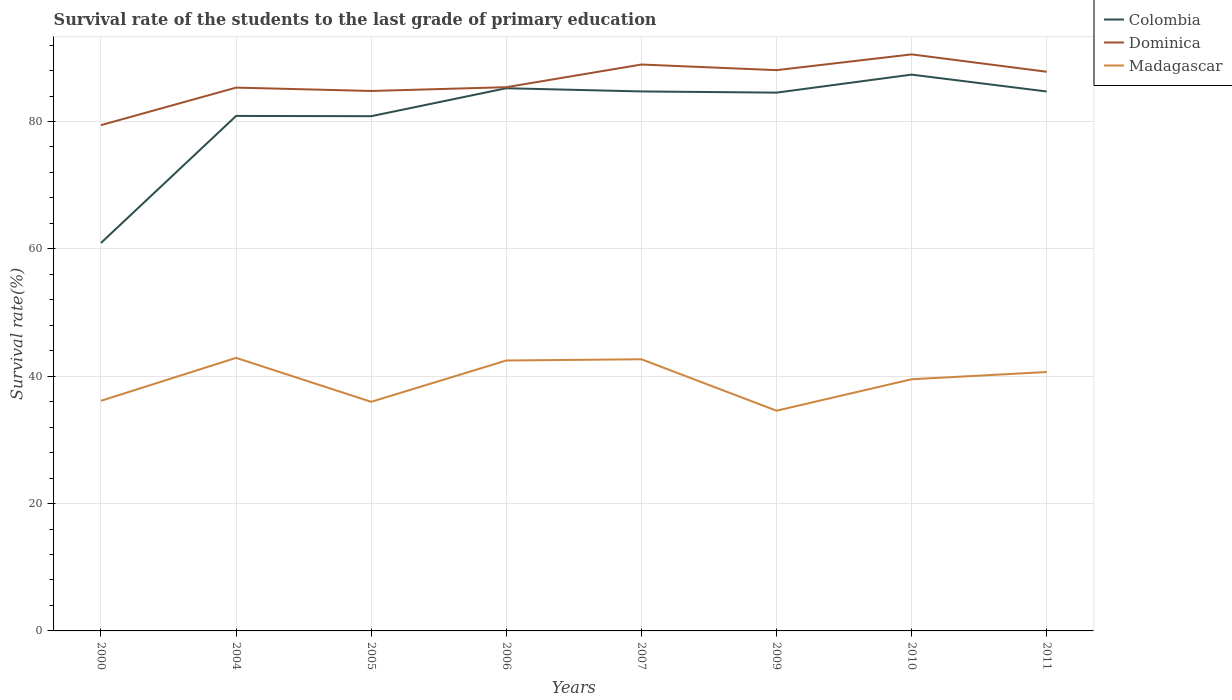Does the line corresponding to Colombia intersect with the line corresponding to Dominica?
Provide a succinct answer. No. Across all years, what is the maximum survival rate of the students in Dominica?
Your response must be concise. 79.43. In which year was the survival rate of the students in Madagascar maximum?
Your answer should be very brief. 2009. What is the total survival rate of the students in Madagascar in the graph?
Your answer should be very brief. 8.3. What is the difference between the highest and the second highest survival rate of the students in Dominica?
Ensure brevity in your answer.  11.11. Is the survival rate of the students in Dominica strictly greater than the survival rate of the students in Colombia over the years?
Make the answer very short. No. How many lines are there?
Your response must be concise. 3. How many years are there in the graph?
Provide a short and direct response. 8. What is the difference between two consecutive major ticks on the Y-axis?
Your answer should be very brief. 20. Are the values on the major ticks of Y-axis written in scientific E-notation?
Offer a terse response. No. Where does the legend appear in the graph?
Make the answer very short. Top right. How are the legend labels stacked?
Make the answer very short. Vertical. What is the title of the graph?
Provide a short and direct response. Survival rate of the students to the last grade of primary education. Does "Colombia" appear as one of the legend labels in the graph?
Provide a short and direct response. Yes. What is the label or title of the X-axis?
Keep it short and to the point. Years. What is the label or title of the Y-axis?
Your response must be concise. Survival rate(%). What is the Survival rate(%) of Colombia in 2000?
Provide a succinct answer. 60.93. What is the Survival rate(%) of Dominica in 2000?
Your response must be concise. 79.43. What is the Survival rate(%) in Madagascar in 2000?
Make the answer very short. 36.14. What is the Survival rate(%) of Colombia in 2004?
Offer a terse response. 80.87. What is the Survival rate(%) in Dominica in 2004?
Your answer should be compact. 85.32. What is the Survival rate(%) of Madagascar in 2004?
Your answer should be very brief. 42.88. What is the Survival rate(%) in Colombia in 2005?
Provide a short and direct response. 80.83. What is the Survival rate(%) in Dominica in 2005?
Ensure brevity in your answer.  84.79. What is the Survival rate(%) of Madagascar in 2005?
Keep it short and to the point. 35.98. What is the Survival rate(%) of Colombia in 2006?
Give a very brief answer. 85.22. What is the Survival rate(%) in Dominica in 2006?
Provide a short and direct response. 85.39. What is the Survival rate(%) in Madagascar in 2006?
Offer a terse response. 42.47. What is the Survival rate(%) of Colombia in 2007?
Provide a succinct answer. 84.72. What is the Survival rate(%) of Dominica in 2007?
Your answer should be compact. 88.94. What is the Survival rate(%) in Madagascar in 2007?
Your answer should be very brief. 42.66. What is the Survival rate(%) of Colombia in 2009?
Your answer should be compact. 84.53. What is the Survival rate(%) in Dominica in 2009?
Provide a succinct answer. 88.06. What is the Survival rate(%) of Madagascar in 2009?
Your answer should be compact. 34.58. What is the Survival rate(%) in Colombia in 2010?
Ensure brevity in your answer.  87.36. What is the Survival rate(%) of Dominica in 2010?
Ensure brevity in your answer.  90.54. What is the Survival rate(%) in Madagascar in 2010?
Ensure brevity in your answer.  39.52. What is the Survival rate(%) of Colombia in 2011?
Ensure brevity in your answer.  84.71. What is the Survival rate(%) in Dominica in 2011?
Your answer should be compact. 87.81. What is the Survival rate(%) of Madagascar in 2011?
Provide a succinct answer. 40.66. Across all years, what is the maximum Survival rate(%) of Colombia?
Keep it short and to the point. 87.36. Across all years, what is the maximum Survival rate(%) in Dominica?
Ensure brevity in your answer.  90.54. Across all years, what is the maximum Survival rate(%) in Madagascar?
Keep it short and to the point. 42.88. Across all years, what is the minimum Survival rate(%) of Colombia?
Provide a short and direct response. 60.93. Across all years, what is the minimum Survival rate(%) in Dominica?
Give a very brief answer. 79.43. Across all years, what is the minimum Survival rate(%) of Madagascar?
Provide a succinct answer. 34.58. What is the total Survival rate(%) of Colombia in the graph?
Offer a very short reply. 649.19. What is the total Survival rate(%) of Dominica in the graph?
Offer a terse response. 690.28. What is the total Survival rate(%) in Madagascar in the graph?
Offer a very short reply. 314.89. What is the difference between the Survival rate(%) of Colombia in 2000 and that in 2004?
Your answer should be compact. -19.94. What is the difference between the Survival rate(%) of Dominica in 2000 and that in 2004?
Provide a succinct answer. -5.89. What is the difference between the Survival rate(%) of Madagascar in 2000 and that in 2004?
Make the answer very short. -6.74. What is the difference between the Survival rate(%) in Colombia in 2000 and that in 2005?
Make the answer very short. -19.9. What is the difference between the Survival rate(%) in Dominica in 2000 and that in 2005?
Your response must be concise. -5.37. What is the difference between the Survival rate(%) in Madagascar in 2000 and that in 2005?
Provide a succinct answer. 0.16. What is the difference between the Survival rate(%) of Colombia in 2000 and that in 2006?
Your answer should be compact. -24.29. What is the difference between the Survival rate(%) in Dominica in 2000 and that in 2006?
Ensure brevity in your answer.  -5.96. What is the difference between the Survival rate(%) of Madagascar in 2000 and that in 2006?
Keep it short and to the point. -6.33. What is the difference between the Survival rate(%) of Colombia in 2000 and that in 2007?
Provide a short and direct response. -23.79. What is the difference between the Survival rate(%) of Dominica in 2000 and that in 2007?
Ensure brevity in your answer.  -9.52. What is the difference between the Survival rate(%) of Madagascar in 2000 and that in 2007?
Your answer should be compact. -6.52. What is the difference between the Survival rate(%) in Colombia in 2000 and that in 2009?
Give a very brief answer. -23.6. What is the difference between the Survival rate(%) of Dominica in 2000 and that in 2009?
Provide a succinct answer. -8.64. What is the difference between the Survival rate(%) in Madagascar in 2000 and that in 2009?
Provide a succinct answer. 1.56. What is the difference between the Survival rate(%) of Colombia in 2000 and that in 2010?
Provide a succinct answer. -26.43. What is the difference between the Survival rate(%) in Dominica in 2000 and that in 2010?
Give a very brief answer. -11.11. What is the difference between the Survival rate(%) of Madagascar in 2000 and that in 2010?
Provide a short and direct response. -3.38. What is the difference between the Survival rate(%) of Colombia in 2000 and that in 2011?
Offer a very short reply. -23.78. What is the difference between the Survival rate(%) of Dominica in 2000 and that in 2011?
Offer a terse response. -8.38. What is the difference between the Survival rate(%) of Madagascar in 2000 and that in 2011?
Give a very brief answer. -4.52. What is the difference between the Survival rate(%) of Colombia in 2004 and that in 2005?
Keep it short and to the point. 0.04. What is the difference between the Survival rate(%) of Dominica in 2004 and that in 2005?
Provide a succinct answer. 0.53. What is the difference between the Survival rate(%) in Madagascar in 2004 and that in 2005?
Give a very brief answer. 6.9. What is the difference between the Survival rate(%) of Colombia in 2004 and that in 2006?
Offer a terse response. -4.35. What is the difference between the Survival rate(%) of Dominica in 2004 and that in 2006?
Offer a terse response. -0.07. What is the difference between the Survival rate(%) of Madagascar in 2004 and that in 2006?
Keep it short and to the point. 0.42. What is the difference between the Survival rate(%) in Colombia in 2004 and that in 2007?
Your answer should be very brief. -3.85. What is the difference between the Survival rate(%) in Dominica in 2004 and that in 2007?
Provide a short and direct response. -3.62. What is the difference between the Survival rate(%) of Madagascar in 2004 and that in 2007?
Offer a terse response. 0.22. What is the difference between the Survival rate(%) of Colombia in 2004 and that in 2009?
Keep it short and to the point. -3.66. What is the difference between the Survival rate(%) of Dominica in 2004 and that in 2009?
Offer a very short reply. -2.74. What is the difference between the Survival rate(%) of Madagascar in 2004 and that in 2009?
Your answer should be compact. 8.3. What is the difference between the Survival rate(%) of Colombia in 2004 and that in 2010?
Offer a very short reply. -6.49. What is the difference between the Survival rate(%) in Dominica in 2004 and that in 2010?
Provide a succinct answer. -5.22. What is the difference between the Survival rate(%) of Madagascar in 2004 and that in 2010?
Provide a short and direct response. 3.36. What is the difference between the Survival rate(%) in Colombia in 2004 and that in 2011?
Your answer should be very brief. -3.84. What is the difference between the Survival rate(%) in Dominica in 2004 and that in 2011?
Offer a terse response. -2.49. What is the difference between the Survival rate(%) of Madagascar in 2004 and that in 2011?
Your answer should be very brief. 2.22. What is the difference between the Survival rate(%) in Colombia in 2005 and that in 2006?
Your answer should be compact. -4.39. What is the difference between the Survival rate(%) of Dominica in 2005 and that in 2006?
Offer a very short reply. -0.59. What is the difference between the Survival rate(%) in Madagascar in 2005 and that in 2006?
Ensure brevity in your answer.  -6.49. What is the difference between the Survival rate(%) of Colombia in 2005 and that in 2007?
Provide a short and direct response. -3.89. What is the difference between the Survival rate(%) in Dominica in 2005 and that in 2007?
Make the answer very short. -4.15. What is the difference between the Survival rate(%) in Madagascar in 2005 and that in 2007?
Give a very brief answer. -6.68. What is the difference between the Survival rate(%) of Colombia in 2005 and that in 2009?
Your answer should be very brief. -3.7. What is the difference between the Survival rate(%) in Dominica in 2005 and that in 2009?
Provide a succinct answer. -3.27. What is the difference between the Survival rate(%) of Madagascar in 2005 and that in 2009?
Your answer should be very brief. 1.39. What is the difference between the Survival rate(%) in Colombia in 2005 and that in 2010?
Your answer should be very brief. -6.53. What is the difference between the Survival rate(%) of Dominica in 2005 and that in 2010?
Make the answer very short. -5.75. What is the difference between the Survival rate(%) of Madagascar in 2005 and that in 2010?
Your answer should be compact. -3.54. What is the difference between the Survival rate(%) in Colombia in 2005 and that in 2011?
Offer a terse response. -3.88. What is the difference between the Survival rate(%) of Dominica in 2005 and that in 2011?
Your answer should be very brief. -3.02. What is the difference between the Survival rate(%) of Madagascar in 2005 and that in 2011?
Offer a terse response. -4.68. What is the difference between the Survival rate(%) in Colombia in 2006 and that in 2007?
Provide a short and direct response. 0.5. What is the difference between the Survival rate(%) in Dominica in 2006 and that in 2007?
Your response must be concise. -3.56. What is the difference between the Survival rate(%) of Madagascar in 2006 and that in 2007?
Keep it short and to the point. -0.19. What is the difference between the Survival rate(%) of Colombia in 2006 and that in 2009?
Your answer should be compact. 0.69. What is the difference between the Survival rate(%) in Dominica in 2006 and that in 2009?
Offer a terse response. -2.68. What is the difference between the Survival rate(%) in Madagascar in 2006 and that in 2009?
Offer a terse response. 7.88. What is the difference between the Survival rate(%) in Colombia in 2006 and that in 2010?
Provide a short and direct response. -2.14. What is the difference between the Survival rate(%) in Dominica in 2006 and that in 2010?
Your answer should be very brief. -5.15. What is the difference between the Survival rate(%) of Madagascar in 2006 and that in 2010?
Your response must be concise. 2.95. What is the difference between the Survival rate(%) of Colombia in 2006 and that in 2011?
Ensure brevity in your answer.  0.51. What is the difference between the Survival rate(%) of Dominica in 2006 and that in 2011?
Offer a very short reply. -2.42. What is the difference between the Survival rate(%) of Madagascar in 2006 and that in 2011?
Your answer should be very brief. 1.81. What is the difference between the Survival rate(%) of Colombia in 2007 and that in 2009?
Your answer should be compact. 0.19. What is the difference between the Survival rate(%) of Dominica in 2007 and that in 2009?
Make the answer very short. 0.88. What is the difference between the Survival rate(%) in Madagascar in 2007 and that in 2009?
Offer a very short reply. 8.08. What is the difference between the Survival rate(%) in Colombia in 2007 and that in 2010?
Provide a short and direct response. -2.64. What is the difference between the Survival rate(%) in Dominica in 2007 and that in 2010?
Keep it short and to the point. -1.59. What is the difference between the Survival rate(%) of Madagascar in 2007 and that in 2010?
Make the answer very short. 3.14. What is the difference between the Survival rate(%) of Colombia in 2007 and that in 2011?
Offer a terse response. 0.01. What is the difference between the Survival rate(%) of Dominica in 2007 and that in 2011?
Offer a terse response. 1.14. What is the difference between the Survival rate(%) in Madagascar in 2007 and that in 2011?
Give a very brief answer. 2. What is the difference between the Survival rate(%) of Colombia in 2009 and that in 2010?
Your answer should be very brief. -2.83. What is the difference between the Survival rate(%) in Dominica in 2009 and that in 2010?
Provide a short and direct response. -2.47. What is the difference between the Survival rate(%) of Madagascar in 2009 and that in 2010?
Provide a short and direct response. -4.93. What is the difference between the Survival rate(%) in Colombia in 2009 and that in 2011?
Offer a terse response. -0.18. What is the difference between the Survival rate(%) in Dominica in 2009 and that in 2011?
Your answer should be very brief. 0.25. What is the difference between the Survival rate(%) of Madagascar in 2009 and that in 2011?
Your answer should be very brief. -6.07. What is the difference between the Survival rate(%) in Colombia in 2010 and that in 2011?
Your answer should be very brief. 2.65. What is the difference between the Survival rate(%) in Dominica in 2010 and that in 2011?
Make the answer very short. 2.73. What is the difference between the Survival rate(%) in Madagascar in 2010 and that in 2011?
Offer a very short reply. -1.14. What is the difference between the Survival rate(%) in Colombia in 2000 and the Survival rate(%) in Dominica in 2004?
Provide a succinct answer. -24.39. What is the difference between the Survival rate(%) in Colombia in 2000 and the Survival rate(%) in Madagascar in 2004?
Offer a terse response. 18.05. What is the difference between the Survival rate(%) in Dominica in 2000 and the Survival rate(%) in Madagascar in 2004?
Keep it short and to the point. 36.55. What is the difference between the Survival rate(%) of Colombia in 2000 and the Survival rate(%) of Dominica in 2005?
Your answer should be compact. -23.86. What is the difference between the Survival rate(%) in Colombia in 2000 and the Survival rate(%) in Madagascar in 2005?
Offer a terse response. 24.95. What is the difference between the Survival rate(%) in Dominica in 2000 and the Survival rate(%) in Madagascar in 2005?
Your answer should be very brief. 43.45. What is the difference between the Survival rate(%) of Colombia in 2000 and the Survival rate(%) of Dominica in 2006?
Your answer should be compact. -24.46. What is the difference between the Survival rate(%) of Colombia in 2000 and the Survival rate(%) of Madagascar in 2006?
Ensure brevity in your answer.  18.46. What is the difference between the Survival rate(%) in Dominica in 2000 and the Survival rate(%) in Madagascar in 2006?
Provide a short and direct response. 36.96. What is the difference between the Survival rate(%) in Colombia in 2000 and the Survival rate(%) in Dominica in 2007?
Provide a succinct answer. -28.01. What is the difference between the Survival rate(%) in Colombia in 2000 and the Survival rate(%) in Madagascar in 2007?
Offer a terse response. 18.27. What is the difference between the Survival rate(%) in Dominica in 2000 and the Survival rate(%) in Madagascar in 2007?
Offer a very short reply. 36.77. What is the difference between the Survival rate(%) of Colombia in 2000 and the Survival rate(%) of Dominica in 2009?
Provide a short and direct response. -27.13. What is the difference between the Survival rate(%) of Colombia in 2000 and the Survival rate(%) of Madagascar in 2009?
Offer a terse response. 26.35. What is the difference between the Survival rate(%) of Dominica in 2000 and the Survival rate(%) of Madagascar in 2009?
Make the answer very short. 44.84. What is the difference between the Survival rate(%) of Colombia in 2000 and the Survival rate(%) of Dominica in 2010?
Keep it short and to the point. -29.61. What is the difference between the Survival rate(%) in Colombia in 2000 and the Survival rate(%) in Madagascar in 2010?
Keep it short and to the point. 21.41. What is the difference between the Survival rate(%) in Dominica in 2000 and the Survival rate(%) in Madagascar in 2010?
Your answer should be very brief. 39.91. What is the difference between the Survival rate(%) in Colombia in 2000 and the Survival rate(%) in Dominica in 2011?
Your answer should be very brief. -26.88. What is the difference between the Survival rate(%) of Colombia in 2000 and the Survival rate(%) of Madagascar in 2011?
Your answer should be compact. 20.27. What is the difference between the Survival rate(%) in Dominica in 2000 and the Survival rate(%) in Madagascar in 2011?
Keep it short and to the point. 38.77. What is the difference between the Survival rate(%) of Colombia in 2004 and the Survival rate(%) of Dominica in 2005?
Offer a terse response. -3.92. What is the difference between the Survival rate(%) of Colombia in 2004 and the Survival rate(%) of Madagascar in 2005?
Keep it short and to the point. 44.89. What is the difference between the Survival rate(%) in Dominica in 2004 and the Survival rate(%) in Madagascar in 2005?
Provide a succinct answer. 49.34. What is the difference between the Survival rate(%) in Colombia in 2004 and the Survival rate(%) in Dominica in 2006?
Give a very brief answer. -4.51. What is the difference between the Survival rate(%) in Colombia in 2004 and the Survival rate(%) in Madagascar in 2006?
Provide a succinct answer. 38.41. What is the difference between the Survival rate(%) of Dominica in 2004 and the Survival rate(%) of Madagascar in 2006?
Make the answer very short. 42.85. What is the difference between the Survival rate(%) in Colombia in 2004 and the Survival rate(%) in Dominica in 2007?
Ensure brevity in your answer.  -8.07. What is the difference between the Survival rate(%) in Colombia in 2004 and the Survival rate(%) in Madagascar in 2007?
Keep it short and to the point. 38.21. What is the difference between the Survival rate(%) of Dominica in 2004 and the Survival rate(%) of Madagascar in 2007?
Offer a terse response. 42.66. What is the difference between the Survival rate(%) in Colombia in 2004 and the Survival rate(%) in Dominica in 2009?
Offer a very short reply. -7.19. What is the difference between the Survival rate(%) of Colombia in 2004 and the Survival rate(%) of Madagascar in 2009?
Ensure brevity in your answer.  46.29. What is the difference between the Survival rate(%) in Dominica in 2004 and the Survival rate(%) in Madagascar in 2009?
Give a very brief answer. 50.74. What is the difference between the Survival rate(%) of Colombia in 2004 and the Survival rate(%) of Dominica in 2010?
Make the answer very short. -9.67. What is the difference between the Survival rate(%) in Colombia in 2004 and the Survival rate(%) in Madagascar in 2010?
Your response must be concise. 41.35. What is the difference between the Survival rate(%) in Dominica in 2004 and the Survival rate(%) in Madagascar in 2010?
Give a very brief answer. 45.8. What is the difference between the Survival rate(%) in Colombia in 2004 and the Survival rate(%) in Dominica in 2011?
Give a very brief answer. -6.94. What is the difference between the Survival rate(%) in Colombia in 2004 and the Survival rate(%) in Madagascar in 2011?
Your answer should be compact. 40.21. What is the difference between the Survival rate(%) in Dominica in 2004 and the Survival rate(%) in Madagascar in 2011?
Give a very brief answer. 44.66. What is the difference between the Survival rate(%) in Colombia in 2005 and the Survival rate(%) in Dominica in 2006?
Your answer should be compact. -4.55. What is the difference between the Survival rate(%) in Colombia in 2005 and the Survival rate(%) in Madagascar in 2006?
Give a very brief answer. 38.37. What is the difference between the Survival rate(%) in Dominica in 2005 and the Survival rate(%) in Madagascar in 2006?
Ensure brevity in your answer.  42.33. What is the difference between the Survival rate(%) in Colombia in 2005 and the Survival rate(%) in Dominica in 2007?
Keep it short and to the point. -8.11. What is the difference between the Survival rate(%) in Colombia in 2005 and the Survival rate(%) in Madagascar in 2007?
Offer a terse response. 38.17. What is the difference between the Survival rate(%) in Dominica in 2005 and the Survival rate(%) in Madagascar in 2007?
Give a very brief answer. 42.13. What is the difference between the Survival rate(%) in Colombia in 2005 and the Survival rate(%) in Dominica in 2009?
Ensure brevity in your answer.  -7.23. What is the difference between the Survival rate(%) in Colombia in 2005 and the Survival rate(%) in Madagascar in 2009?
Provide a short and direct response. 46.25. What is the difference between the Survival rate(%) in Dominica in 2005 and the Survival rate(%) in Madagascar in 2009?
Ensure brevity in your answer.  50.21. What is the difference between the Survival rate(%) in Colombia in 2005 and the Survival rate(%) in Dominica in 2010?
Keep it short and to the point. -9.71. What is the difference between the Survival rate(%) of Colombia in 2005 and the Survival rate(%) of Madagascar in 2010?
Offer a very short reply. 41.31. What is the difference between the Survival rate(%) of Dominica in 2005 and the Survival rate(%) of Madagascar in 2010?
Offer a terse response. 45.27. What is the difference between the Survival rate(%) of Colombia in 2005 and the Survival rate(%) of Dominica in 2011?
Offer a terse response. -6.98. What is the difference between the Survival rate(%) in Colombia in 2005 and the Survival rate(%) in Madagascar in 2011?
Give a very brief answer. 40.17. What is the difference between the Survival rate(%) of Dominica in 2005 and the Survival rate(%) of Madagascar in 2011?
Provide a succinct answer. 44.13. What is the difference between the Survival rate(%) in Colombia in 2006 and the Survival rate(%) in Dominica in 2007?
Offer a terse response. -3.72. What is the difference between the Survival rate(%) of Colombia in 2006 and the Survival rate(%) of Madagascar in 2007?
Provide a short and direct response. 42.56. What is the difference between the Survival rate(%) of Dominica in 2006 and the Survival rate(%) of Madagascar in 2007?
Your answer should be compact. 42.73. What is the difference between the Survival rate(%) of Colombia in 2006 and the Survival rate(%) of Dominica in 2009?
Make the answer very short. -2.84. What is the difference between the Survival rate(%) of Colombia in 2006 and the Survival rate(%) of Madagascar in 2009?
Make the answer very short. 50.64. What is the difference between the Survival rate(%) of Dominica in 2006 and the Survival rate(%) of Madagascar in 2009?
Provide a succinct answer. 50.8. What is the difference between the Survival rate(%) of Colombia in 2006 and the Survival rate(%) of Dominica in 2010?
Provide a short and direct response. -5.32. What is the difference between the Survival rate(%) in Colombia in 2006 and the Survival rate(%) in Madagascar in 2010?
Offer a very short reply. 45.7. What is the difference between the Survival rate(%) in Dominica in 2006 and the Survival rate(%) in Madagascar in 2010?
Ensure brevity in your answer.  45.87. What is the difference between the Survival rate(%) in Colombia in 2006 and the Survival rate(%) in Dominica in 2011?
Your answer should be compact. -2.59. What is the difference between the Survival rate(%) of Colombia in 2006 and the Survival rate(%) of Madagascar in 2011?
Your answer should be compact. 44.56. What is the difference between the Survival rate(%) of Dominica in 2006 and the Survival rate(%) of Madagascar in 2011?
Offer a terse response. 44.73. What is the difference between the Survival rate(%) in Colombia in 2007 and the Survival rate(%) in Dominica in 2009?
Make the answer very short. -3.34. What is the difference between the Survival rate(%) of Colombia in 2007 and the Survival rate(%) of Madagascar in 2009?
Offer a terse response. 50.14. What is the difference between the Survival rate(%) of Dominica in 2007 and the Survival rate(%) of Madagascar in 2009?
Your response must be concise. 54.36. What is the difference between the Survival rate(%) in Colombia in 2007 and the Survival rate(%) in Dominica in 2010?
Keep it short and to the point. -5.82. What is the difference between the Survival rate(%) in Colombia in 2007 and the Survival rate(%) in Madagascar in 2010?
Offer a terse response. 45.2. What is the difference between the Survival rate(%) in Dominica in 2007 and the Survival rate(%) in Madagascar in 2010?
Offer a very short reply. 49.43. What is the difference between the Survival rate(%) of Colombia in 2007 and the Survival rate(%) of Dominica in 2011?
Offer a very short reply. -3.09. What is the difference between the Survival rate(%) of Colombia in 2007 and the Survival rate(%) of Madagascar in 2011?
Make the answer very short. 44.06. What is the difference between the Survival rate(%) of Dominica in 2007 and the Survival rate(%) of Madagascar in 2011?
Your answer should be very brief. 48.29. What is the difference between the Survival rate(%) of Colombia in 2009 and the Survival rate(%) of Dominica in 2010?
Keep it short and to the point. -6.01. What is the difference between the Survival rate(%) in Colombia in 2009 and the Survival rate(%) in Madagascar in 2010?
Offer a very short reply. 45.01. What is the difference between the Survival rate(%) in Dominica in 2009 and the Survival rate(%) in Madagascar in 2010?
Your answer should be very brief. 48.54. What is the difference between the Survival rate(%) of Colombia in 2009 and the Survival rate(%) of Dominica in 2011?
Provide a short and direct response. -3.28. What is the difference between the Survival rate(%) of Colombia in 2009 and the Survival rate(%) of Madagascar in 2011?
Offer a very short reply. 43.87. What is the difference between the Survival rate(%) in Dominica in 2009 and the Survival rate(%) in Madagascar in 2011?
Provide a succinct answer. 47.4. What is the difference between the Survival rate(%) in Colombia in 2010 and the Survival rate(%) in Dominica in 2011?
Offer a very short reply. -0.45. What is the difference between the Survival rate(%) in Colombia in 2010 and the Survival rate(%) in Madagascar in 2011?
Offer a terse response. 46.7. What is the difference between the Survival rate(%) of Dominica in 2010 and the Survival rate(%) of Madagascar in 2011?
Offer a terse response. 49.88. What is the average Survival rate(%) of Colombia per year?
Your answer should be compact. 81.15. What is the average Survival rate(%) in Dominica per year?
Your answer should be compact. 86.29. What is the average Survival rate(%) in Madagascar per year?
Offer a terse response. 39.36. In the year 2000, what is the difference between the Survival rate(%) of Colombia and Survival rate(%) of Dominica?
Ensure brevity in your answer.  -18.5. In the year 2000, what is the difference between the Survival rate(%) in Colombia and Survival rate(%) in Madagascar?
Ensure brevity in your answer.  24.79. In the year 2000, what is the difference between the Survival rate(%) of Dominica and Survival rate(%) of Madagascar?
Your answer should be compact. 43.29. In the year 2004, what is the difference between the Survival rate(%) of Colombia and Survival rate(%) of Dominica?
Ensure brevity in your answer.  -4.45. In the year 2004, what is the difference between the Survival rate(%) in Colombia and Survival rate(%) in Madagascar?
Ensure brevity in your answer.  37.99. In the year 2004, what is the difference between the Survival rate(%) of Dominica and Survival rate(%) of Madagascar?
Offer a terse response. 42.44. In the year 2005, what is the difference between the Survival rate(%) in Colombia and Survival rate(%) in Dominica?
Keep it short and to the point. -3.96. In the year 2005, what is the difference between the Survival rate(%) in Colombia and Survival rate(%) in Madagascar?
Give a very brief answer. 44.85. In the year 2005, what is the difference between the Survival rate(%) of Dominica and Survival rate(%) of Madagascar?
Your answer should be compact. 48.81. In the year 2006, what is the difference between the Survival rate(%) in Colombia and Survival rate(%) in Dominica?
Give a very brief answer. -0.16. In the year 2006, what is the difference between the Survival rate(%) of Colombia and Survival rate(%) of Madagascar?
Your answer should be very brief. 42.76. In the year 2006, what is the difference between the Survival rate(%) in Dominica and Survival rate(%) in Madagascar?
Offer a terse response. 42.92. In the year 2007, what is the difference between the Survival rate(%) in Colombia and Survival rate(%) in Dominica?
Provide a succinct answer. -4.22. In the year 2007, what is the difference between the Survival rate(%) of Colombia and Survival rate(%) of Madagascar?
Make the answer very short. 42.06. In the year 2007, what is the difference between the Survival rate(%) of Dominica and Survival rate(%) of Madagascar?
Make the answer very short. 46.28. In the year 2009, what is the difference between the Survival rate(%) in Colombia and Survival rate(%) in Dominica?
Your answer should be compact. -3.53. In the year 2009, what is the difference between the Survival rate(%) of Colombia and Survival rate(%) of Madagascar?
Ensure brevity in your answer.  49.95. In the year 2009, what is the difference between the Survival rate(%) of Dominica and Survival rate(%) of Madagascar?
Your answer should be compact. 53.48. In the year 2010, what is the difference between the Survival rate(%) of Colombia and Survival rate(%) of Dominica?
Your answer should be compact. -3.18. In the year 2010, what is the difference between the Survival rate(%) of Colombia and Survival rate(%) of Madagascar?
Your response must be concise. 47.84. In the year 2010, what is the difference between the Survival rate(%) in Dominica and Survival rate(%) in Madagascar?
Offer a terse response. 51.02. In the year 2011, what is the difference between the Survival rate(%) of Colombia and Survival rate(%) of Dominica?
Your answer should be compact. -3.1. In the year 2011, what is the difference between the Survival rate(%) of Colombia and Survival rate(%) of Madagascar?
Ensure brevity in your answer.  44.05. In the year 2011, what is the difference between the Survival rate(%) of Dominica and Survival rate(%) of Madagascar?
Your response must be concise. 47.15. What is the ratio of the Survival rate(%) of Colombia in 2000 to that in 2004?
Ensure brevity in your answer.  0.75. What is the ratio of the Survival rate(%) in Dominica in 2000 to that in 2004?
Provide a succinct answer. 0.93. What is the ratio of the Survival rate(%) of Madagascar in 2000 to that in 2004?
Offer a very short reply. 0.84. What is the ratio of the Survival rate(%) of Colombia in 2000 to that in 2005?
Keep it short and to the point. 0.75. What is the ratio of the Survival rate(%) in Dominica in 2000 to that in 2005?
Your answer should be compact. 0.94. What is the ratio of the Survival rate(%) of Colombia in 2000 to that in 2006?
Provide a short and direct response. 0.71. What is the ratio of the Survival rate(%) of Dominica in 2000 to that in 2006?
Ensure brevity in your answer.  0.93. What is the ratio of the Survival rate(%) in Madagascar in 2000 to that in 2006?
Offer a very short reply. 0.85. What is the ratio of the Survival rate(%) of Colombia in 2000 to that in 2007?
Ensure brevity in your answer.  0.72. What is the ratio of the Survival rate(%) of Dominica in 2000 to that in 2007?
Give a very brief answer. 0.89. What is the ratio of the Survival rate(%) of Madagascar in 2000 to that in 2007?
Your answer should be compact. 0.85. What is the ratio of the Survival rate(%) in Colombia in 2000 to that in 2009?
Make the answer very short. 0.72. What is the ratio of the Survival rate(%) in Dominica in 2000 to that in 2009?
Your response must be concise. 0.9. What is the ratio of the Survival rate(%) of Madagascar in 2000 to that in 2009?
Ensure brevity in your answer.  1.04. What is the ratio of the Survival rate(%) of Colombia in 2000 to that in 2010?
Your answer should be very brief. 0.7. What is the ratio of the Survival rate(%) in Dominica in 2000 to that in 2010?
Offer a very short reply. 0.88. What is the ratio of the Survival rate(%) in Madagascar in 2000 to that in 2010?
Keep it short and to the point. 0.91. What is the ratio of the Survival rate(%) of Colombia in 2000 to that in 2011?
Provide a short and direct response. 0.72. What is the ratio of the Survival rate(%) in Dominica in 2000 to that in 2011?
Your response must be concise. 0.9. What is the ratio of the Survival rate(%) of Madagascar in 2000 to that in 2011?
Make the answer very short. 0.89. What is the ratio of the Survival rate(%) in Colombia in 2004 to that in 2005?
Ensure brevity in your answer.  1. What is the ratio of the Survival rate(%) of Madagascar in 2004 to that in 2005?
Offer a very short reply. 1.19. What is the ratio of the Survival rate(%) in Colombia in 2004 to that in 2006?
Provide a short and direct response. 0.95. What is the ratio of the Survival rate(%) in Madagascar in 2004 to that in 2006?
Offer a terse response. 1.01. What is the ratio of the Survival rate(%) of Colombia in 2004 to that in 2007?
Offer a very short reply. 0.95. What is the ratio of the Survival rate(%) in Dominica in 2004 to that in 2007?
Ensure brevity in your answer.  0.96. What is the ratio of the Survival rate(%) of Madagascar in 2004 to that in 2007?
Your answer should be very brief. 1.01. What is the ratio of the Survival rate(%) of Colombia in 2004 to that in 2009?
Give a very brief answer. 0.96. What is the ratio of the Survival rate(%) of Dominica in 2004 to that in 2009?
Keep it short and to the point. 0.97. What is the ratio of the Survival rate(%) of Madagascar in 2004 to that in 2009?
Provide a short and direct response. 1.24. What is the ratio of the Survival rate(%) in Colombia in 2004 to that in 2010?
Your answer should be compact. 0.93. What is the ratio of the Survival rate(%) of Dominica in 2004 to that in 2010?
Provide a succinct answer. 0.94. What is the ratio of the Survival rate(%) of Madagascar in 2004 to that in 2010?
Offer a very short reply. 1.09. What is the ratio of the Survival rate(%) of Colombia in 2004 to that in 2011?
Your answer should be compact. 0.95. What is the ratio of the Survival rate(%) in Dominica in 2004 to that in 2011?
Your answer should be very brief. 0.97. What is the ratio of the Survival rate(%) in Madagascar in 2004 to that in 2011?
Keep it short and to the point. 1.05. What is the ratio of the Survival rate(%) in Colombia in 2005 to that in 2006?
Provide a short and direct response. 0.95. What is the ratio of the Survival rate(%) in Dominica in 2005 to that in 2006?
Offer a terse response. 0.99. What is the ratio of the Survival rate(%) in Madagascar in 2005 to that in 2006?
Make the answer very short. 0.85. What is the ratio of the Survival rate(%) of Colombia in 2005 to that in 2007?
Offer a terse response. 0.95. What is the ratio of the Survival rate(%) of Dominica in 2005 to that in 2007?
Make the answer very short. 0.95. What is the ratio of the Survival rate(%) of Madagascar in 2005 to that in 2007?
Your response must be concise. 0.84. What is the ratio of the Survival rate(%) of Colombia in 2005 to that in 2009?
Provide a succinct answer. 0.96. What is the ratio of the Survival rate(%) in Dominica in 2005 to that in 2009?
Give a very brief answer. 0.96. What is the ratio of the Survival rate(%) in Madagascar in 2005 to that in 2009?
Give a very brief answer. 1.04. What is the ratio of the Survival rate(%) of Colombia in 2005 to that in 2010?
Your response must be concise. 0.93. What is the ratio of the Survival rate(%) in Dominica in 2005 to that in 2010?
Make the answer very short. 0.94. What is the ratio of the Survival rate(%) of Madagascar in 2005 to that in 2010?
Ensure brevity in your answer.  0.91. What is the ratio of the Survival rate(%) of Colombia in 2005 to that in 2011?
Provide a succinct answer. 0.95. What is the ratio of the Survival rate(%) in Dominica in 2005 to that in 2011?
Offer a very short reply. 0.97. What is the ratio of the Survival rate(%) of Madagascar in 2005 to that in 2011?
Make the answer very short. 0.88. What is the ratio of the Survival rate(%) of Colombia in 2006 to that in 2007?
Offer a terse response. 1.01. What is the ratio of the Survival rate(%) in Madagascar in 2006 to that in 2007?
Keep it short and to the point. 1. What is the ratio of the Survival rate(%) in Colombia in 2006 to that in 2009?
Provide a succinct answer. 1.01. What is the ratio of the Survival rate(%) of Dominica in 2006 to that in 2009?
Ensure brevity in your answer.  0.97. What is the ratio of the Survival rate(%) of Madagascar in 2006 to that in 2009?
Ensure brevity in your answer.  1.23. What is the ratio of the Survival rate(%) in Colombia in 2006 to that in 2010?
Provide a succinct answer. 0.98. What is the ratio of the Survival rate(%) of Dominica in 2006 to that in 2010?
Offer a terse response. 0.94. What is the ratio of the Survival rate(%) in Madagascar in 2006 to that in 2010?
Give a very brief answer. 1.07. What is the ratio of the Survival rate(%) of Dominica in 2006 to that in 2011?
Give a very brief answer. 0.97. What is the ratio of the Survival rate(%) in Madagascar in 2006 to that in 2011?
Provide a succinct answer. 1.04. What is the ratio of the Survival rate(%) of Colombia in 2007 to that in 2009?
Give a very brief answer. 1. What is the ratio of the Survival rate(%) in Dominica in 2007 to that in 2009?
Make the answer very short. 1.01. What is the ratio of the Survival rate(%) of Madagascar in 2007 to that in 2009?
Your response must be concise. 1.23. What is the ratio of the Survival rate(%) in Colombia in 2007 to that in 2010?
Your answer should be very brief. 0.97. What is the ratio of the Survival rate(%) in Dominica in 2007 to that in 2010?
Your answer should be compact. 0.98. What is the ratio of the Survival rate(%) in Madagascar in 2007 to that in 2010?
Your answer should be very brief. 1.08. What is the ratio of the Survival rate(%) in Colombia in 2007 to that in 2011?
Your answer should be very brief. 1. What is the ratio of the Survival rate(%) in Dominica in 2007 to that in 2011?
Offer a terse response. 1.01. What is the ratio of the Survival rate(%) in Madagascar in 2007 to that in 2011?
Ensure brevity in your answer.  1.05. What is the ratio of the Survival rate(%) in Colombia in 2009 to that in 2010?
Provide a succinct answer. 0.97. What is the ratio of the Survival rate(%) of Dominica in 2009 to that in 2010?
Keep it short and to the point. 0.97. What is the ratio of the Survival rate(%) of Madagascar in 2009 to that in 2010?
Ensure brevity in your answer.  0.88. What is the ratio of the Survival rate(%) in Colombia in 2009 to that in 2011?
Ensure brevity in your answer.  1. What is the ratio of the Survival rate(%) of Dominica in 2009 to that in 2011?
Your response must be concise. 1. What is the ratio of the Survival rate(%) of Madagascar in 2009 to that in 2011?
Keep it short and to the point. 0.85. What is the ratio of the Survival rate(%) of Colombia in 2010 to that in 2011?
Ensure brevity in your answer.  1.03. What is the ratio of the Survival rate(%) of Dominica in 2010 to that in 2011?
Ensure brevity in your answer.  1.03. What is the ratio of the Survival rate(%) in Madagascar in 2010 to that in 2011?
Make the answer very short. 0.97. What is the difference between the highest and the second highest Survival rate(%) of Colombia?
Provide a short and direct response. 2.14. What is the difference between the highest and the second highest Survival rate(%) in Dominica?
Keep it short and to the point. 1.59. What is the difference between the highest and the second highest Survival rate(%) of Madagascar?
Offer a very short reply. 0.22. What is the difference between the highest and the lowest Survival rate(%) of Colombia?
Provide a short and direct response. 26.43. What is the difference between the highest and the lowest Survival rate(%) in Dominica?
Offer a terse response. 11.11. What is the difference between the highest and the lowest Survival rate(%) in Madagascar?
Offer a terse response. 8.3. 